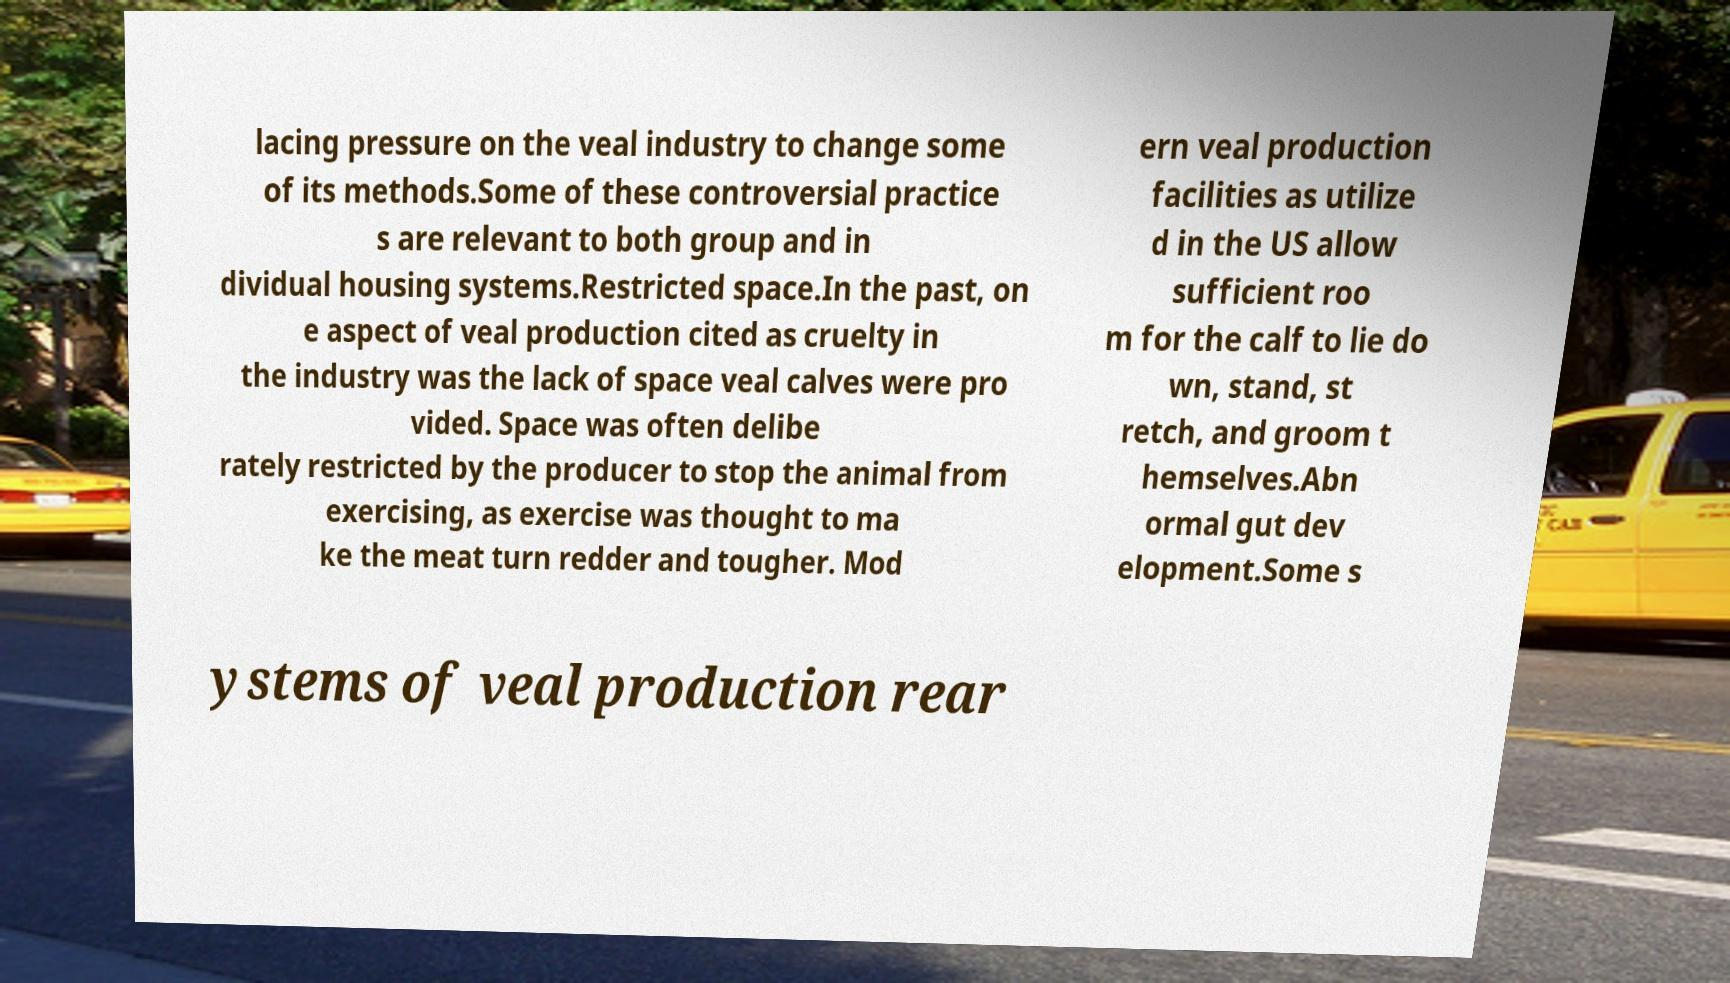I need the written content from this picture converted into text. Can you do that? lacing pressure on the veal industry to change some of its methods.Some of these controversial practice s are relevant to both group and in dividual housing systems.Restricted space.In the past, on e aspect of veal production cited as cruelty in the industry was the lack of space veal calves were pro vided. Space was often delibe rately restricted by the producer to stop the animal from exercising, as exercise was thought to ma ke the meat turn redder and tougher. Mod ern veal production facilities as utilize d in the US allow sufficient roo m for the calf to lie do wn, stand, st retch, and groom t hemselves.Abn ormal gut dev elopment.Some s ystems of veal production rear 